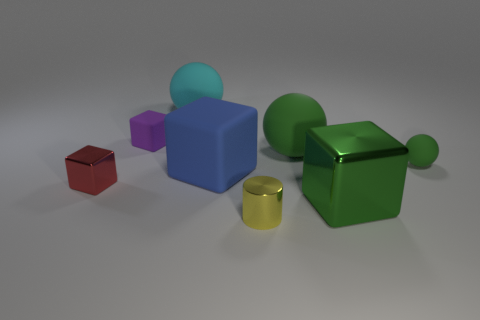Add 2 blue blocks. How many objects exist? 10 Subtract all balls. How many objects are left? 5 Subtract 1 blue blocks. How many objects are left? 7 Subtract all brown shiny things. Subtract all green metal objects. How many objects are left? 7 Add 6 large blue cubes. How many large blue cubes are left? 7 Add 7 blue matte spheres. How many blue matte spheres exist? 7 